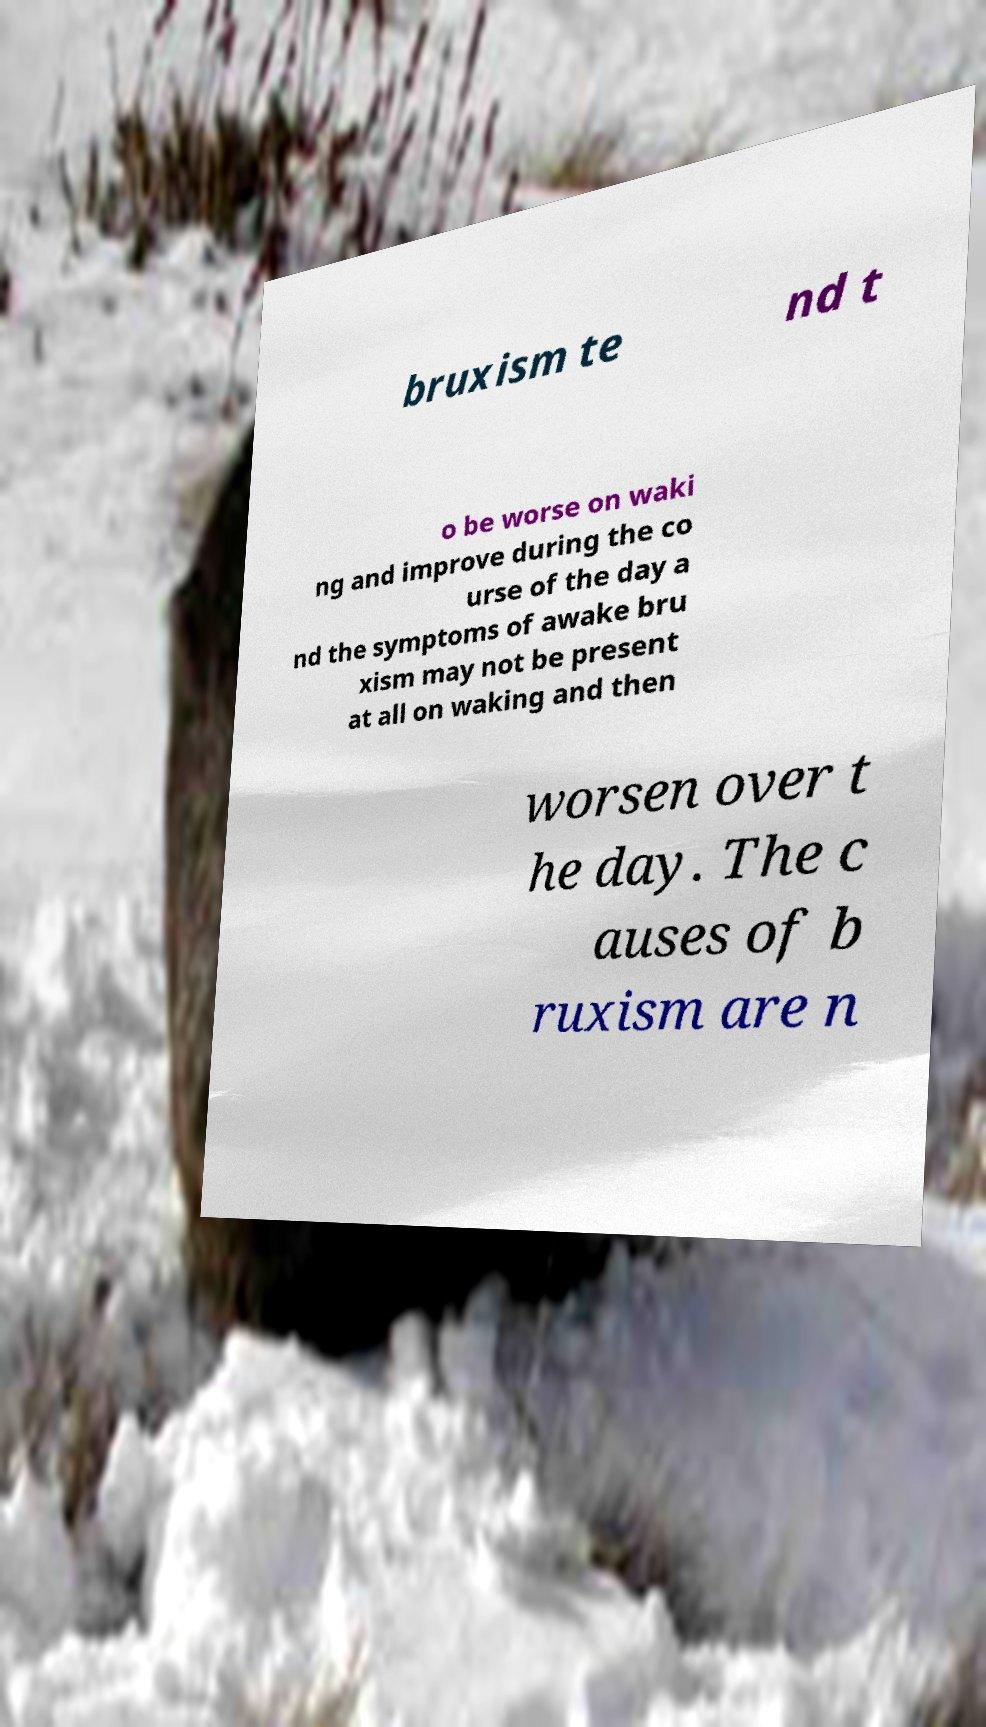Could you extract and type out the text from this image? bruxism te nd t o be worse on waki ng and improve during the co urse of the day a nd the symptoms of awake bru xism may not be present at all on waking and then worsen over t he day. The c auses of b ruxism are n 